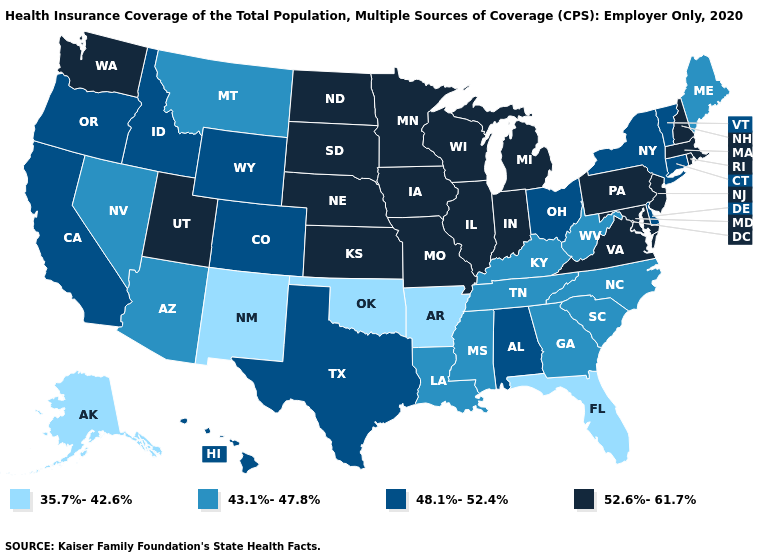Is the legend a continuous bar?
Keep it brief. No. Name the states that have a value in the range 48.1%-52.4%?
Short answer required. Alabama, California, Colorado, Connecticut, Delaware, Hawaii, Idaho, New York, Ohio, Oregon, Texas, Vermont, Wyoming. What is the highest value in the MidWest ?
Keep it brief. 52.6%-61.7%. Does Maryland have the highest value in the South?
Keep it brief. Yes. What is the highest value in the South ?
Be succinct. 52.6%-61.7%. Among the states that border Nebraska , which have the highest value?
Be succinct. Iowa, Kansas, Missouri, South Dakota. Does Ohio have the highest value in the MidWest?
Keep it brief. No. How many symbols are there in the legend?
Be succinct. 4. Name the states that have a value in the range 43.1%-47.8%?
Short answer required. Arizona, Georgia, Kentucky, Louisiana, Maine, Mississippi, Montana, Nevada, North Carolina, South Carolina, Tennessee, West Virginia. Does Louisiana have the same value as Rhode Island?
Be succinct. No. Does Iowa have the highest value in the MidWest?
Concise answer only. Yes. Name the states that have a value in the range 35.7%-42.6%?
Short answer required. Alaska, Arkansas, Florida, New Mexico, Oklahoma. What is the value of Alaska?
Short answer required. 35.7%-42.6%. What is the value of New Hampshire?
Short answer required. 52.6%-61.7%. Does Arkansas have the lowest value in the USA?
Answer briefly. Yes. 